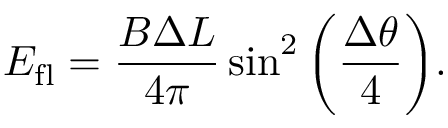<formula> <loc_0><loc_0><loc_500><loc_500>E _ { f l } = \frac { B \Delta L } { 4 \pi } \sin ^ { 2 } \left ( { \frac { \Delta \theta } { 4 } } \right ) .</formula> 